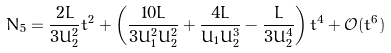Convert formula to latex. <formula><loc_0><loc_0><loc_500><loc_500>N _ { 5 } = \frac { 2 L } { 3 U _ { 2 } ^ { 2 } } t ^ { 2 } + \left ( \frac { 1 0 L } { 3 U _ { 1 } ^ { 2 } U _ { 2 } ^ { 2 } } + \frac { 4 L } { U _ { 1 } U _ { 2 } ^ { 3 } } - \frac { L } { 3 U _ { 2 } ^ { 4 } } \right ) t ^ { 4 } + \mathcal { O } ( t ^ { 6 } )</formula> 